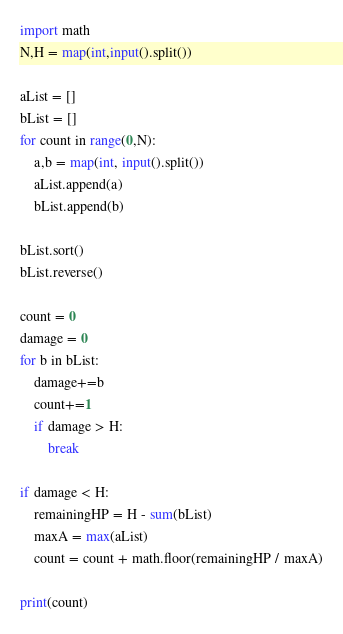Convert code to text. <code><loc_0><loc_0><loc_500><loc_500><_Python_>import math
N,H = map(int,input().split())

aList = []
bList = []
for count in range(0,N):
    a,b = map(int, input().split())
    aList.append(a)
    bList.append(b)

bList.sort()
bList.reverse()

count = 0
damage = 0
for b in bList:
    damage+=b
    count+=1
    if damage > H:
        break

if damage < H:
    remainingHP = H - sum(bList)
    maxA = max(aList)
    count = count + math.floor(remainingHP / maxA)

print(count)</code> 